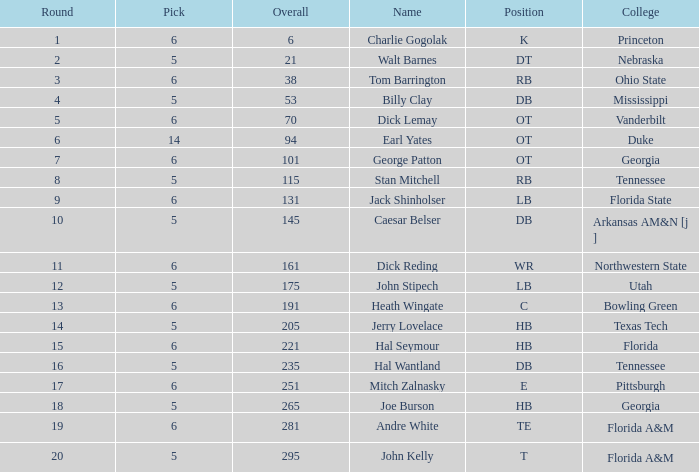What is the maximum pick, when round exceeds 15, and when college is "tennessee"? 5.0. 